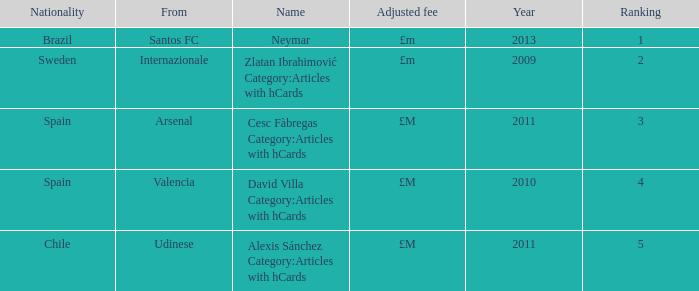Where is the ranked 2 players from? Internazionale. 